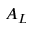Convert formula to latex. <formula><loc_0><loc_0><loc_500><loc_500>A _ { L }</formula> 